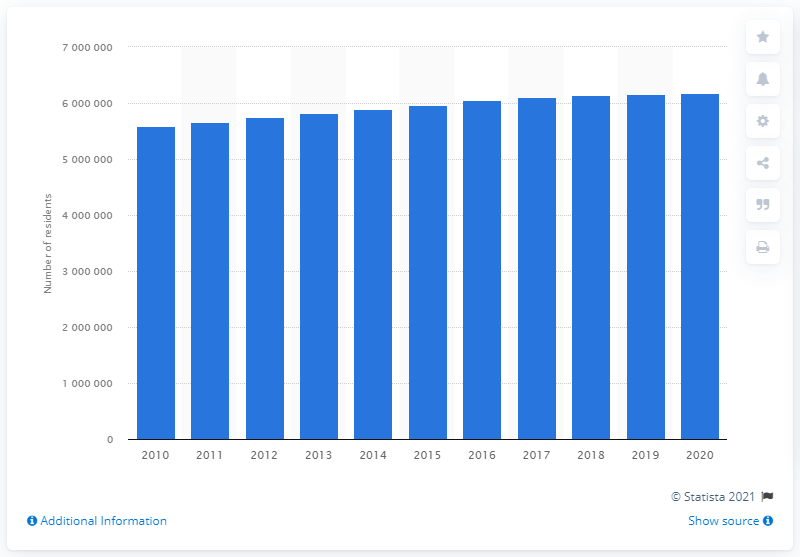Highlight a few significant elements in this photo. The population of Miami-Fort Lauderdale-Pompano Beach in the previous year was 6115654, according to the information provided. In 2020, the population of Miami-Fort Lauderdale-Pompano Beach was 6115654, indicating a significant increase from the previous year. 